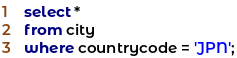<code> <loc_0><loc_0><loc_500><loc_500><_SQL_>select *
from city
where countrycode = 'JPN';
</code> 